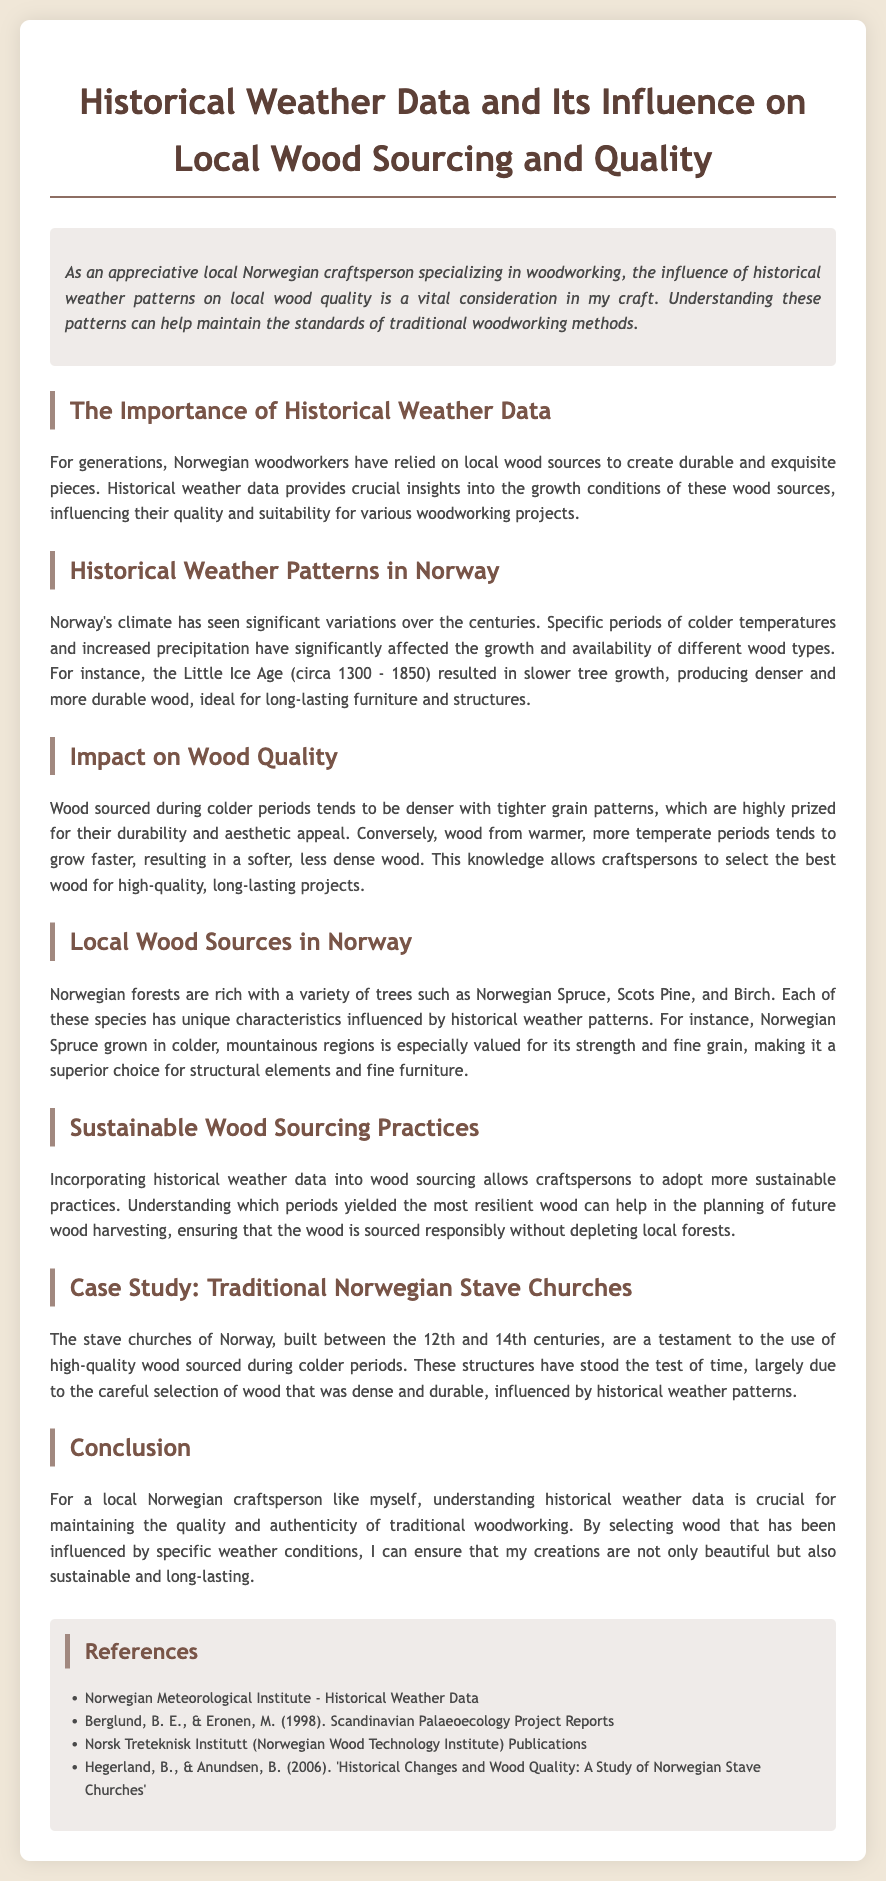what is the title of the document? The title is indicated in the header section of the document.
Answer: Historical Weather Data and Its Influence on Local Wood Sourcing and Quality what period is referred to as the Little Ice Age? The document mentions this historical climate period specifically in the context of its effects on wood quality.
Answer: circa 1300 - 1850 which type of wood is specifically valued for its strength and fine grain? The document discusses various wood types and specifies one that has unique characteristics influenced by weather patterns.
Answer: Norwegian Spruce what characteristic does wood sourced during colder periods tend to have? The document describes the general qualities of wood depending on the temperatures during its growth phase.
Answer: denser what role does historical weather data play in sustainable wood sourcing practices? This aspect is discussed in relation to how understanding past growth conditions can aid in responsible harvesting.
Answer: helps in planning what construction is mentioned as a case study in the document? The document highlights a specific traditional structure to illustrate the practical implications of wood sourcing.
Answer: traditional Norwegian Stave Churches what is the primary focus of local Norwegian craftspersons according to the document? The main theme discussed in the document emphasizes the importance of wood quality and sourcing for craftspersons.
Answer: woodworking 